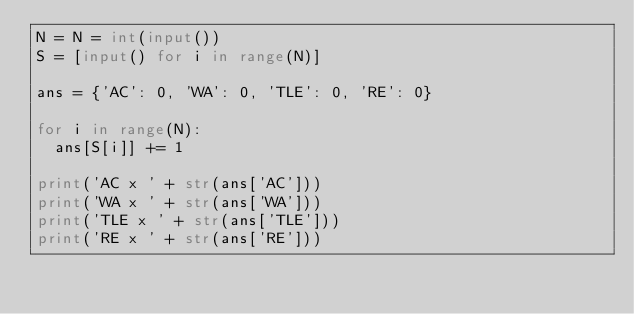<code> <loc_0><loc_0><loc_500><loc_500><_Python_>N = N = int(input())
S = [input() for i in range(N)]

ans = {'AC': 0, 'WA': 0, 'TLE': 0, 'RE': 0}

for i in range(N):
  ans[S[i]] += 1
  
print('AC x ' + str(ans['AC']))
print('WA x ' + str(ans['WA']))
print('TLE x ' + str(ans['TLE']))
print('RE x ' + str(ans['RE']))</code> 